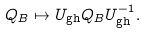<formula> <loc_0><loc_0><loc_500><loc_500>Q _ { B } \mapsto U _ { \text {gh} } Q _ { B } U ^ { - 1 } _ { \text {gh} } .</formula> 